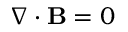<formula> <loc_0><loc_0><loc_500><loc_500>\nabla \cdot \mathbf B = 0</formula> 